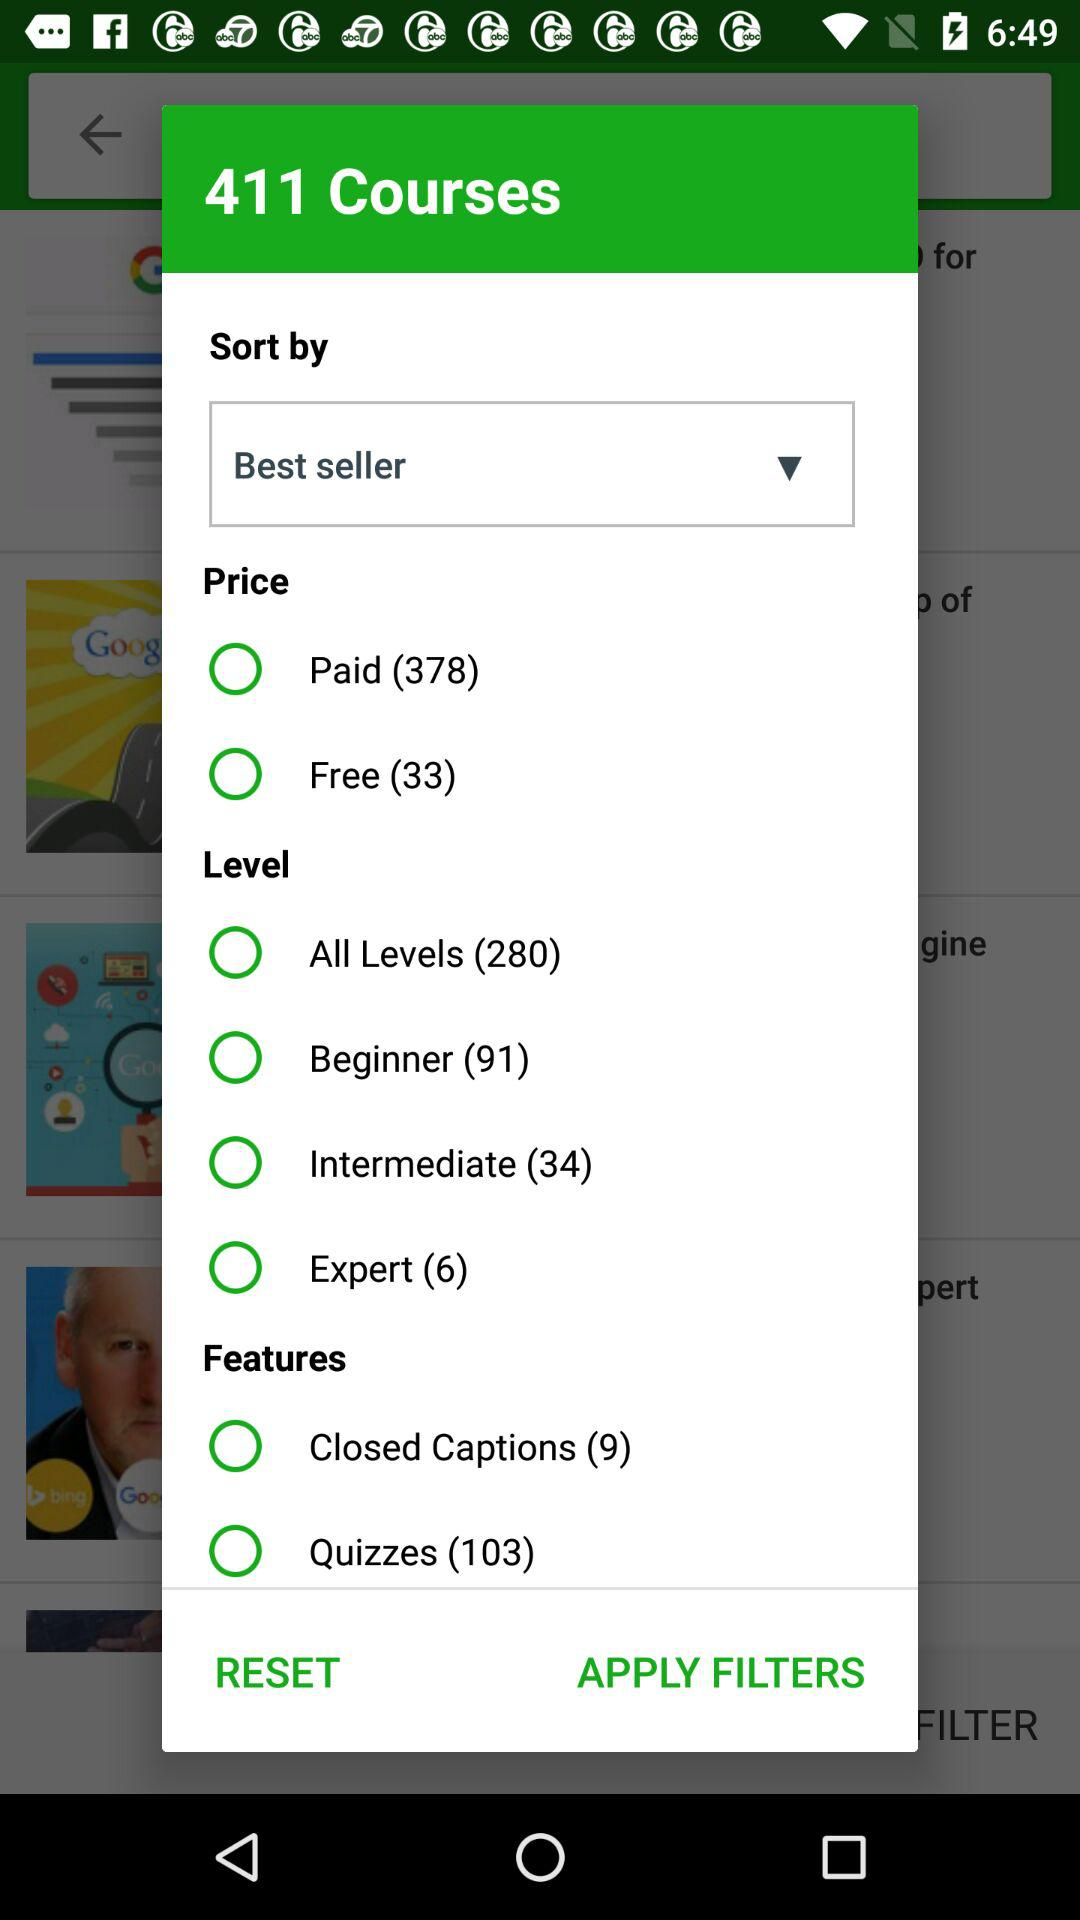How many expert-level courses are present? There are six expert-level courses present. 